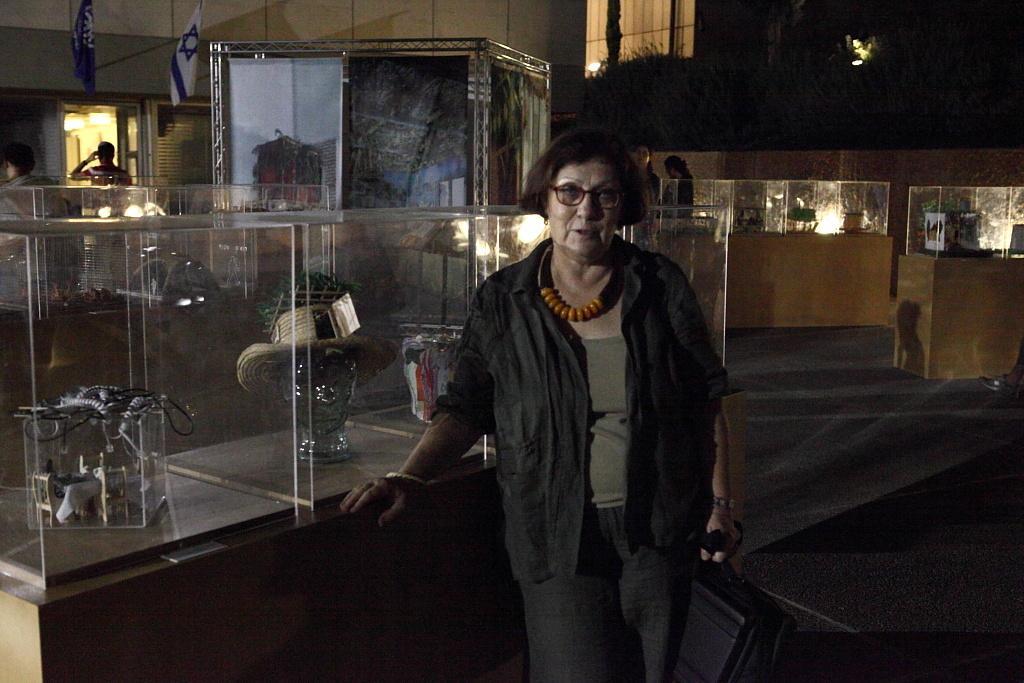Please provide a concise description of this image. In the middle of the image there is a lady with spectacles is standing and holding a bag in the hand. Behind her there is a table with glass boxes. In the middle of the box there is a crystal object with a hat on it. In the background there are there are few tables with glass boxes and inside them there are a few things. And also there are poster and few people. And also there is a building with walls, windows and glass doors. 